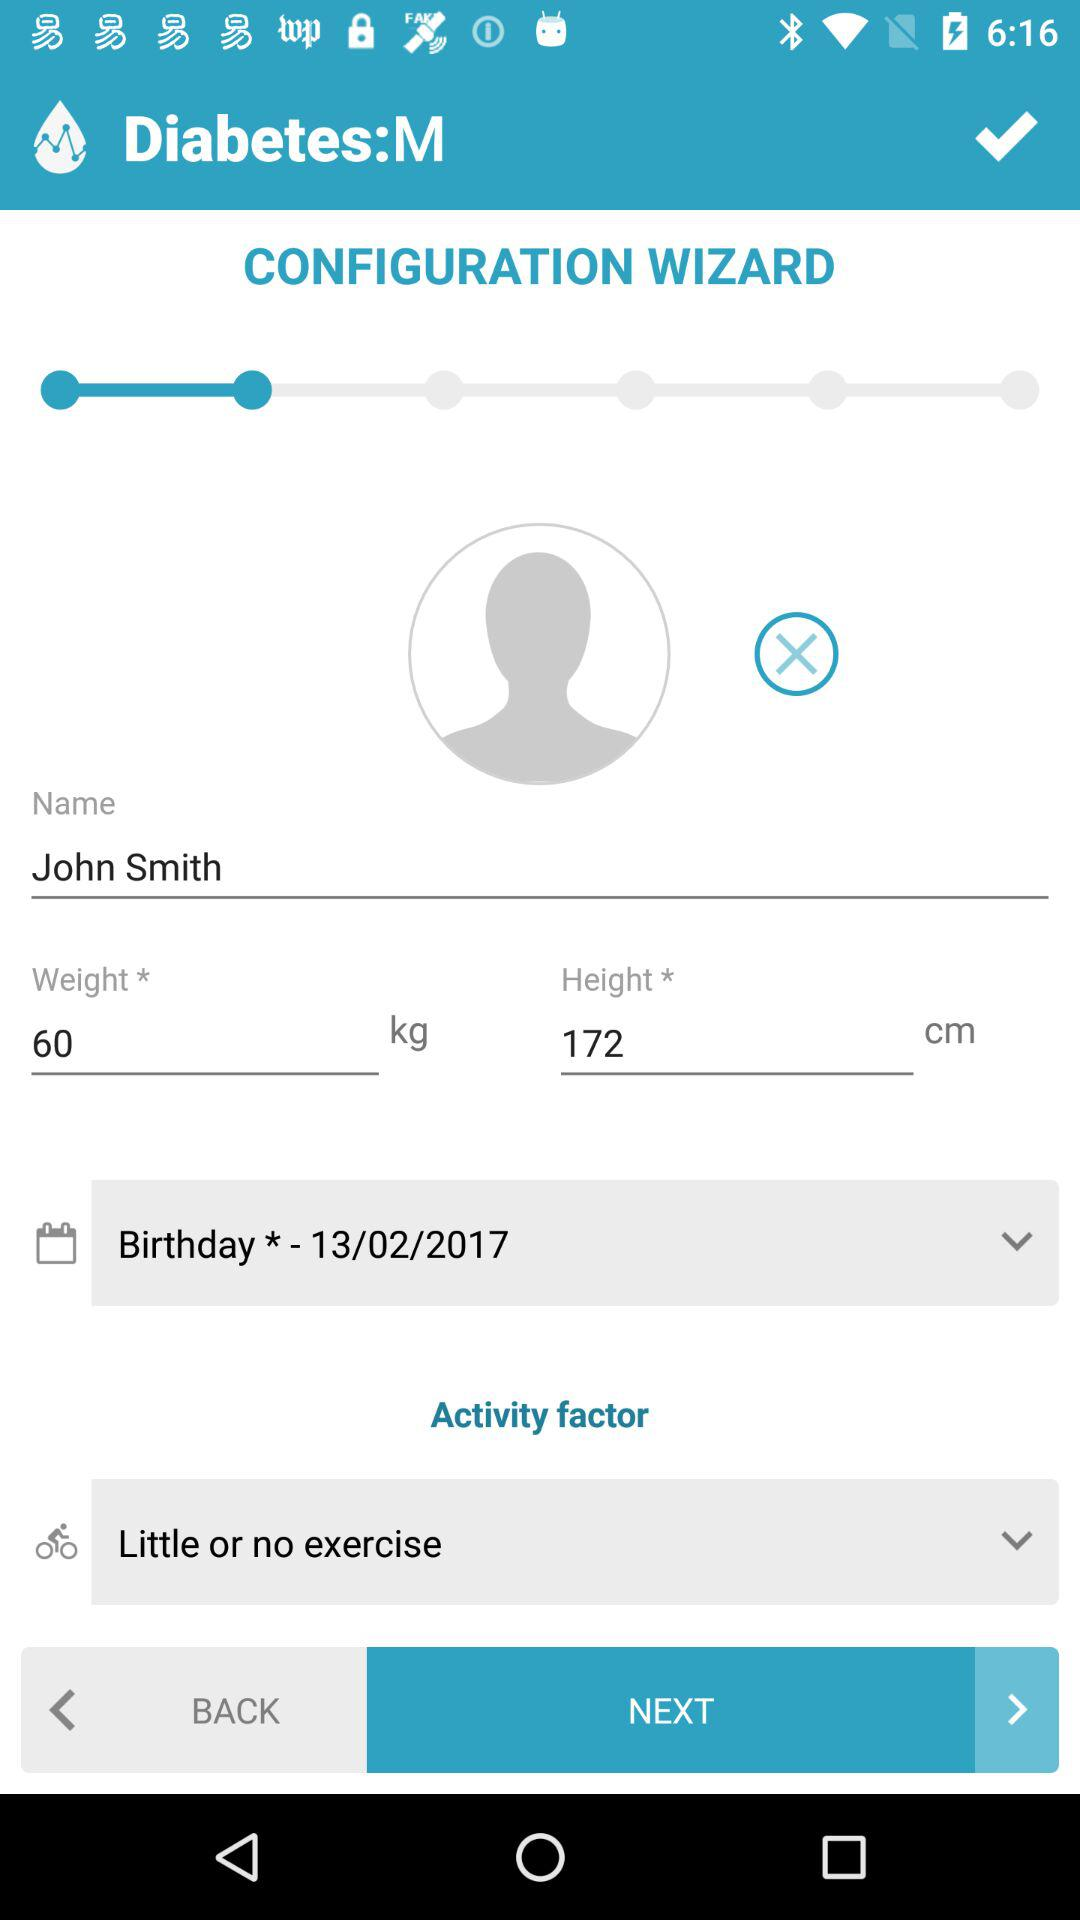How much more tall is the user than they weigh?
Answer the question using a single word or phrase. 112 